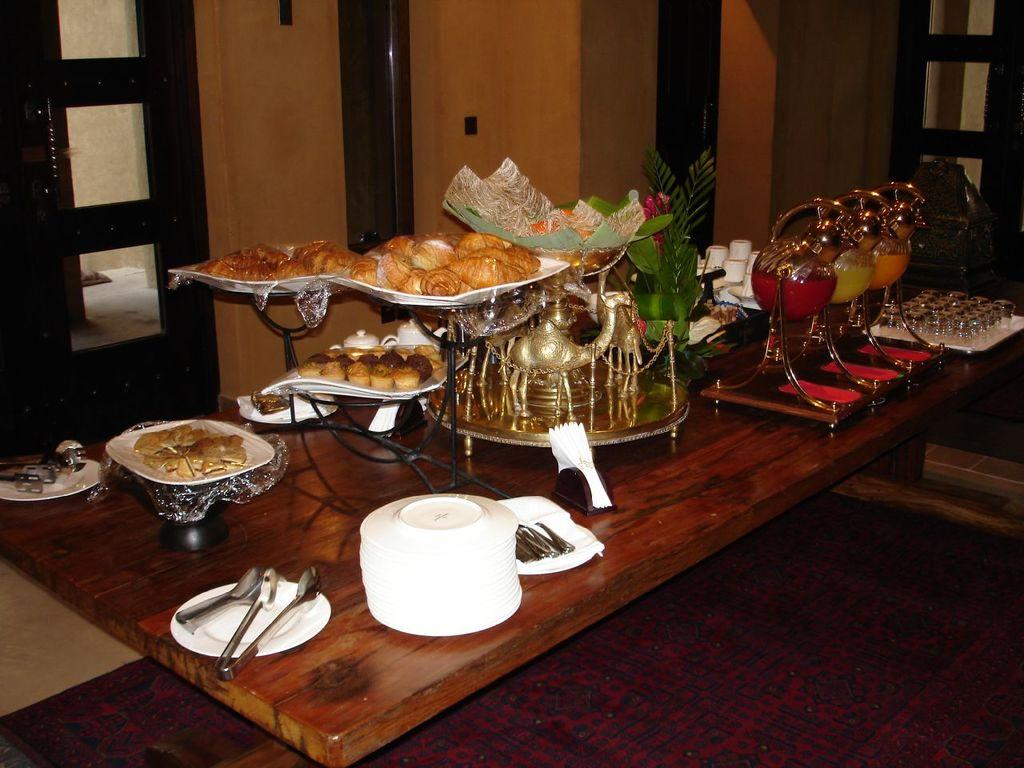What piece of furniture is present in the image? There is a table in the image. What is on the table? There is food on the table. What are the plates used for in the image? The plates are used for holding food. What utensils are on the table? There are spoons on the table. What can be seen in the background of the image? There is a door and a wall in the background of the image. What type of shelf is visible in the image? There is no shelf present in the image. What kind of produce can be seen on the table in the image? There is no produce visible on the table in the image. 